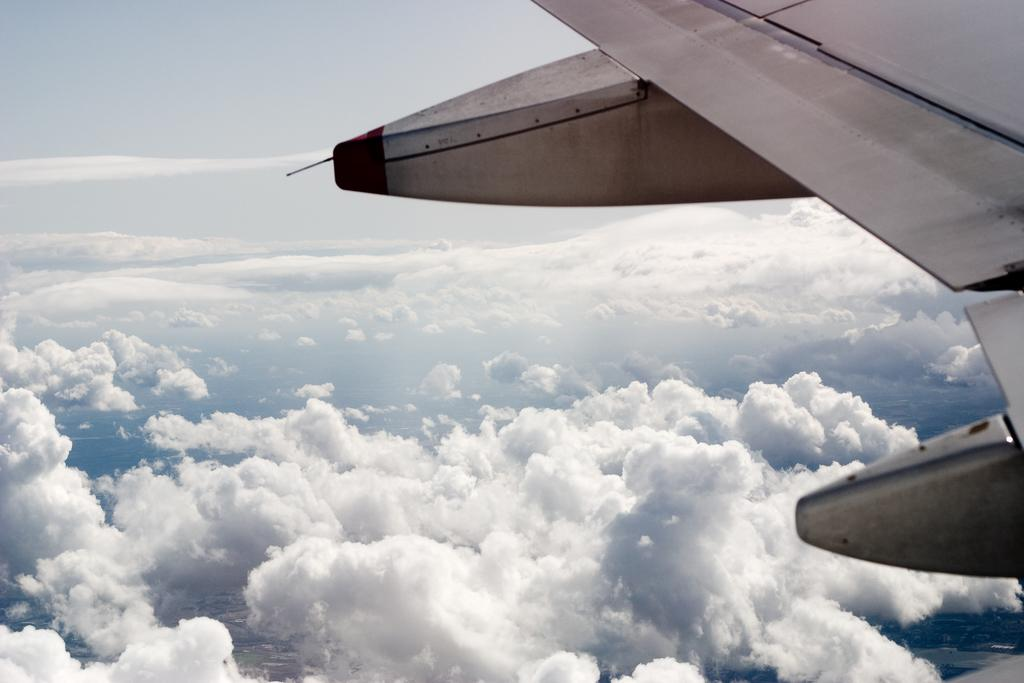What type of vehicle is partially visible in the image? There is a part of an aircraft in the image. What can be seen in the sky in the image? There are clouds visible in the sky. Who is the owner of the music playing in the image? There is no music or owner mentioned in the image. 